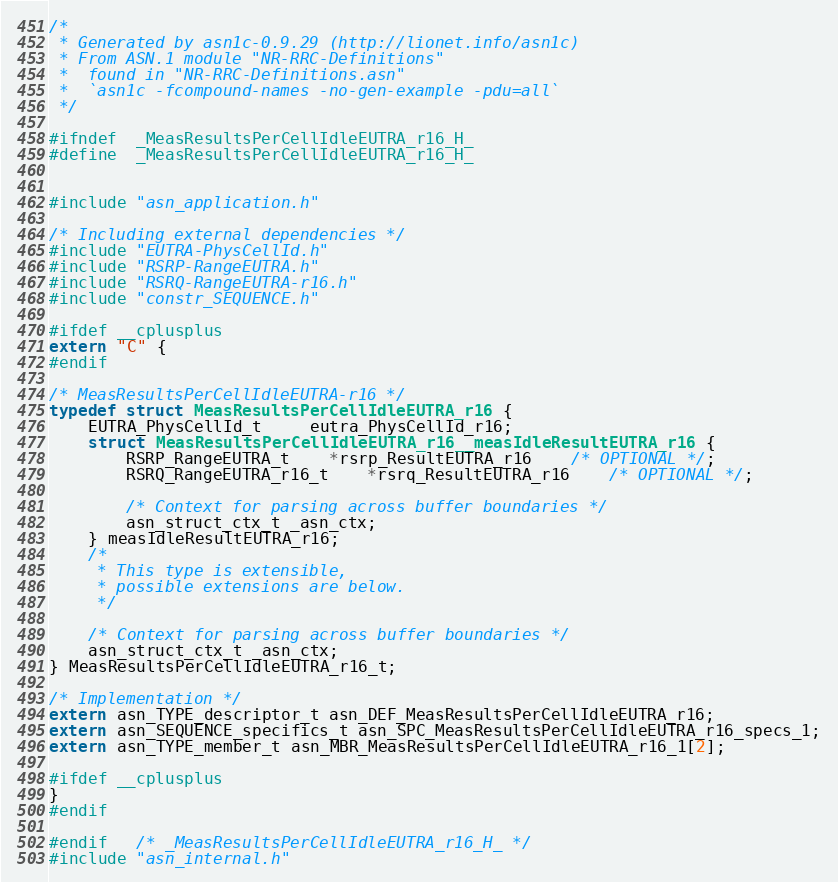<code> <loc_0><loc_0><loc_500><loc_500><_C_>/*
 * Generated by asn1c-0.9.29 (http://lionet.info/asn1c)
 * From ASN.1 module "NR-RRC-Definitions"
 * 	found in "NR-RRC-Definitions.asn"
 * 	`asn1c -fcompound-names -no-gen-example -pdu=all`
 */

#ifndef	_MeasResultsPerCellIdleEUTRA_r16_H_
#define	_MeasResultsPerCellIdleEUTRA_r16_H_


#include "asn_application.h"

/* Including external dependencies */
#include "EUTRA-PhysCellId.h"
#include "RSRP-RangeEUTRA.h"
#include "RSRQ-RangeEUTRA-r16.h"
#include "constr_SEQUENCE.h"

#ifdef __cplusplus
extern "C" {
#endif

/* MeasResultsPerCellIdleEUTRA-r16 */
typedef struct MeasResultsPerCellIdleEUTRA_r16 {
	EUTRA_PhysCellId_t	 eutra_PhysCellId_r16;
	struct MeasResultsPerCellIdleEUTRA_r16__measIdleResultEUTRA_r16 {
		RSRP_RangeEUTRA_t	*rsrp_ResultEUTRA_r16	/* OPTIONAL */;
		RSRQ_RangeEUTRA_r16_t	*rsrq_ResultEUTRA_r16	/* OPTIONAL */;
		
		/* Context for parsing across buffer boundaries */
		asn_struct_ctx_t _asn_ctx;
	} measIdleResultEUTRA_r16;
	/*
	 * This type is extensible,
	 * possible extensions are below.
	 */
	
	/* Context for parsing across buffer boundaries */
	asn_struct_ctx_t _asn_ctx;
} MeasResultsPerCellIdleEUTRA_r16_t;

/* Implementation */
extern asn_TYPE_descriptor_t asn_DEF_MeasResultsPerCellIdleEUTRA_r16;
extern asn_SEQUENCE_specifics_t asn_SPC_MeasResultsPerCellIdleEUTRA_r16_specs_1;
extern asn_TYPE_member_t asn_MBR_MeasResultsPerCellIdleEUTRA_r16_1[2];

#ifdef __cplusplus
}
#endif

#endif	/* _MeasResultsPerCellIdleEUTRA_r16_H_ */
#include "asn_internal.h"
</code> 